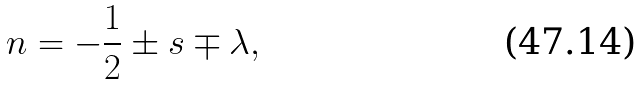Convert formula to latex. <formula><loc_0><loc_0><loc_500><loc_500>n = - \frac { 1 } { 2 } \pm s \mp \lambda ,</formula> 